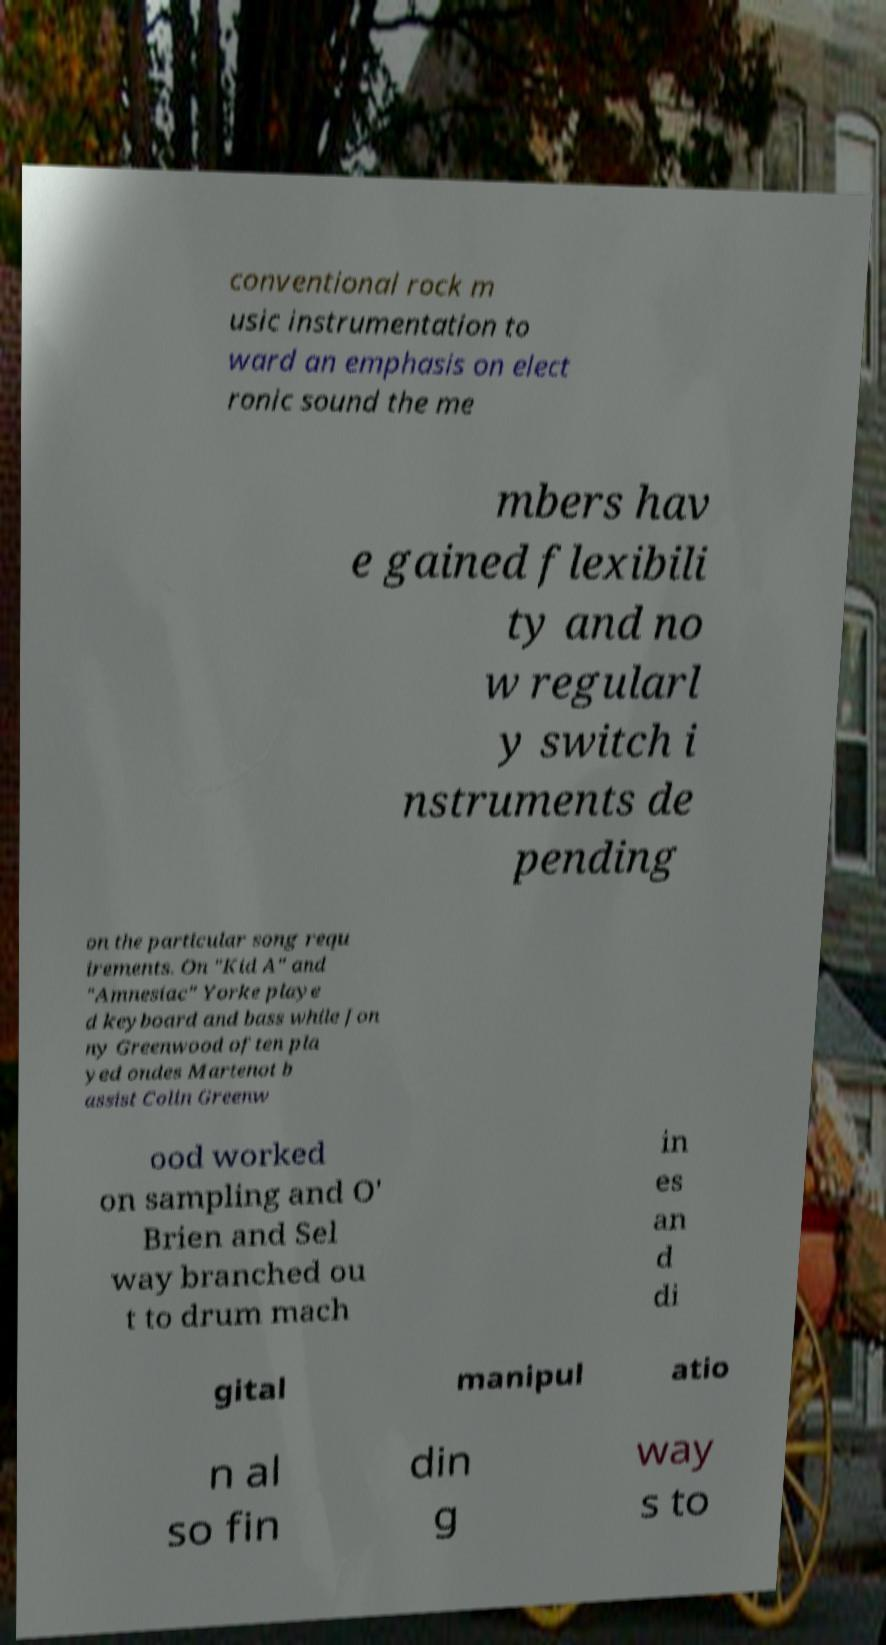Can you accurately transcribe the text from the provided image for me? conventional rock m usic instrumentation to ward an emphasis on elect ronic sound the me mbers hav e gained flexibili ty and no w regularl y switch i nstruments de pending on the particular song requ irements. On "Kid A" and "Amnesiac" Yorke playe d keyboard and bass while Jon ny Greenwood often pla yed ondes Martenot b assist Colin Greenw ood worked on sampling and O' Brien and Sel way branched ou t to drum mach in es an d di gital manipul atio n al so fin din g way s to 